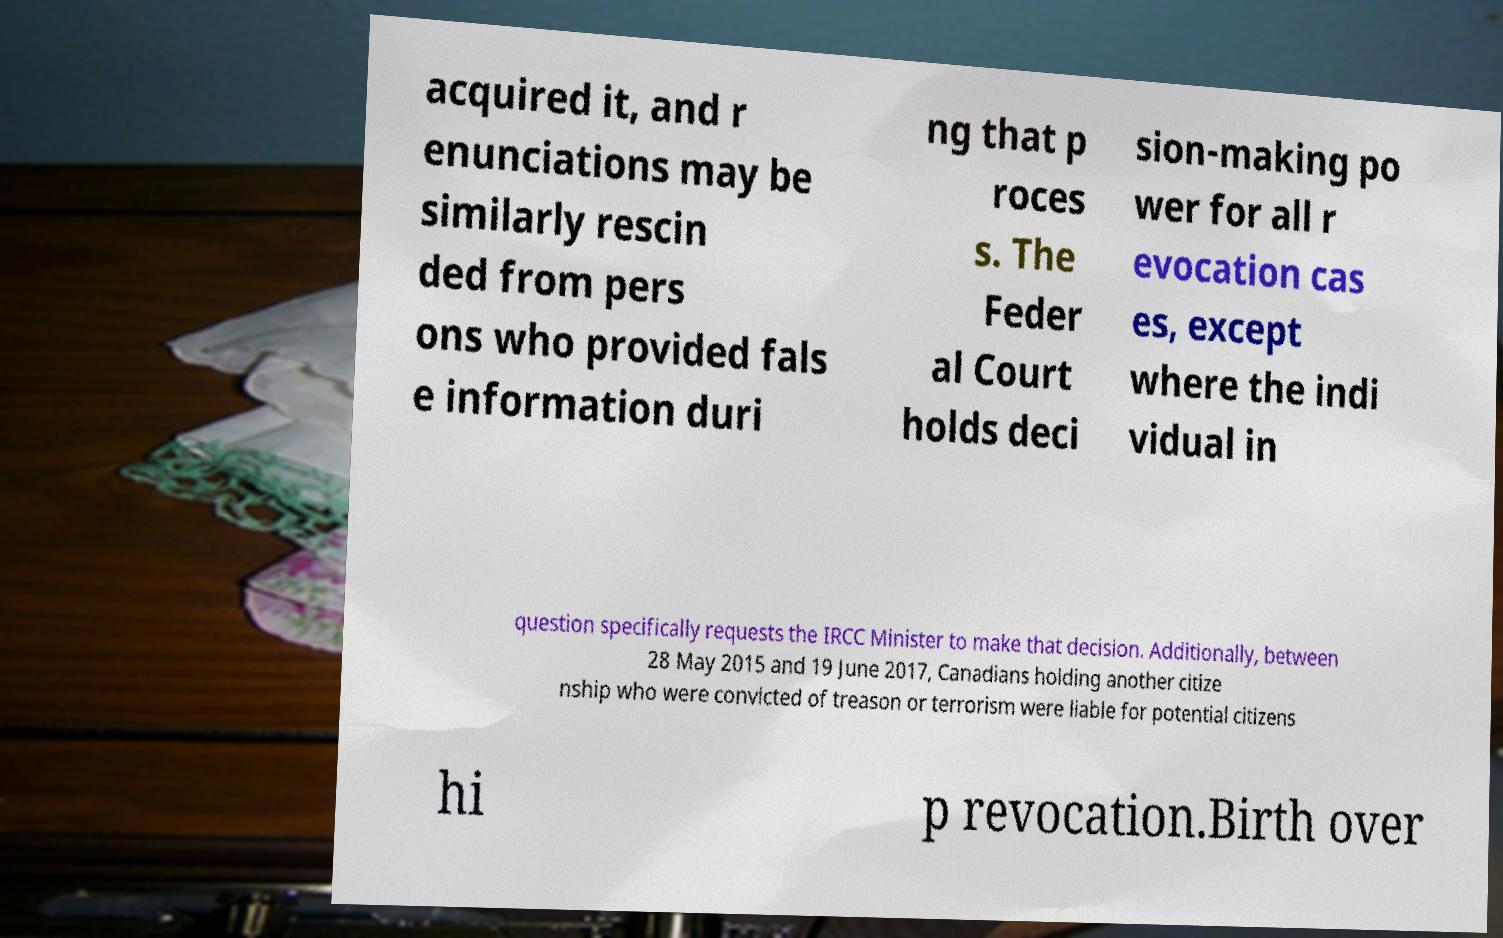What messages or text are displayed in this image? I need them in a readable, typed format. acquired it, and r enunciations may be similarly rescin ded from pers ons who provided fals e information duri ng that p roces s. The Feder al Court holds deci sion-making po wer for all r evocation cas es, except where the indi vidual in question specifically requests the IRCC Minister to make that decision. Additionally, between 28 May 2015 and 19 June 2017, Canadians holding another citize nship who were convicted of treason or terrorism were liable for potential citizens hi p revocation.Birth over 